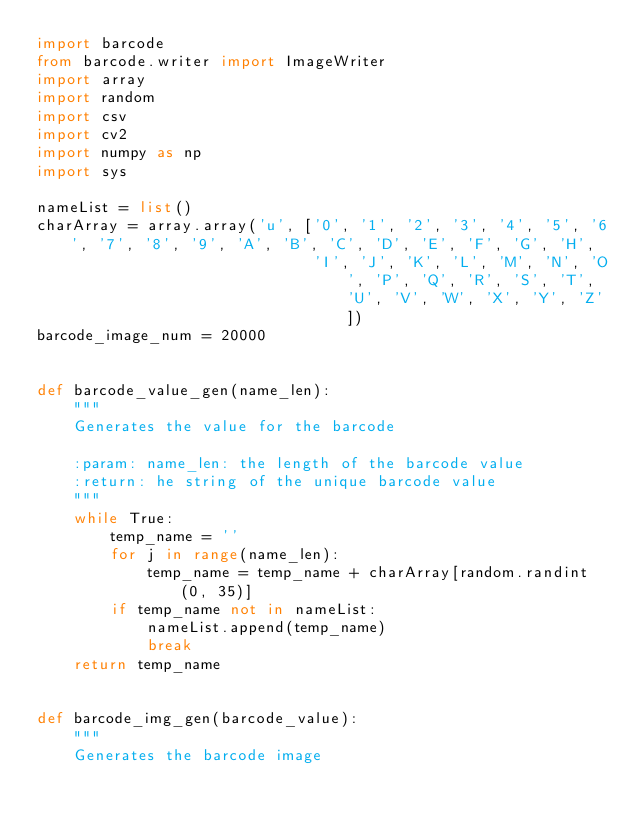Convert code to text. <code><loc_0><loc_0><loc_500><loc_500><_Python_>import barcode
from barcode.writer import ImageWriter
import array
import random
import csv
import cv2
import numpy as np
import sys

nameList = list()
charArray = array.array('u', ['0', '1', '2', '3', '4', '5', '6', '7', '8', '9', 'A', 'B', 'C', 'D', 'E', 'F', 'G', 'H',
                              'I', 'J', 'K', 'L', 'M', 'N', 'O', 'P', 'Q', 'R', 'S', 'T', 'U', 'V', 'W', 'X', 'Y', 'Z'])
barcode_image_num = 20000


def barcode_value_gen(name_len):
    """
    Generates the value for the barcode

    :param: name_len: the length of the barcode value
    :return: he string of the unique barcode value
    """
    while True:
        temp_name = ''
        for j in range(name_len):
            temp_name = temp_name + charArray[random.randint(0, 35)]
        if temp_name not in nameList:
            nameList.append(temp_name)
            break
    return temp_name


def barcode_img_gen(barcode_value):
    """
    Generates the barcode image
</code> 